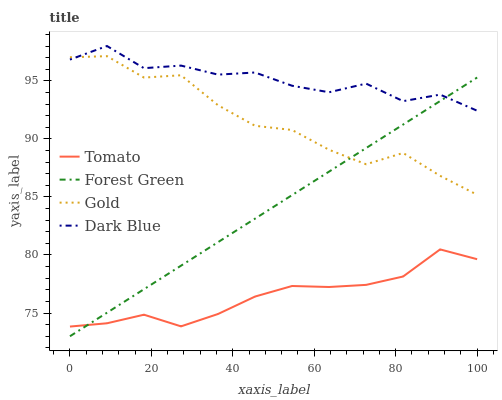Does Tomato have the minimum area under the curve?
Answer yes or no. Yes. Does Dark Blue have the maximum area under the curve?
Answer yes or no. Yes. Does Forest Green have the minimum area under the curve?
Answer yes or no. No. Does Forest Green have the maximum area under the curve?
Answer yes or no. No. Is Forest Green the smoothest?
Answer yes or no. Yes. Is Dark Blue the roughest?
Answer yes or no. Yes. Is Dark Blue the smoothest?
Answer yes or no. No. Is Forest Green the roughest?
Answer yes or no. No. Does Forest Green have the lowest value?
Answer yes or no. Yes. Does Dark Blue have the lowest value?
Answer yes or no. No. Does Dark Blue have the highest value?
Answer yes or no. Yes. Does Forest Green have the highest value?
Answer yes or no. No. Is Tomato less than Dark Blue?
Answer yes or no. Yes. Is Dark Blue greater than Tomato?
Answer yes or no. Yes. Does Gold intersect Forest Green?
Answer yes or no. Yes. Is Gold less than Forest Green?
Answer yes or no. No. Is Gold greater than Forest Green?
Answer yes or no. No. Does Tomato intersect Dark Blue?
Answer yes or no. No. 